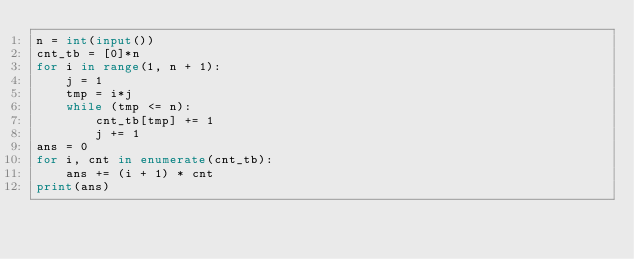Convert code to text. <code><loc_0><loc_0><loc_500><loc_500><_Python_>n = int(input())
cnt_tb = [0]*n
for i in range(1, n + 1):
    j = 1
    tmp = i*j
    while (tmp <= n):
        cnt_tb[tmp] += 1
        j += 1
ans = 0
for i, cnt in enumerate(cnt_tb):
    ans += (i + 1) * cnt
print(ans)
    </code> 